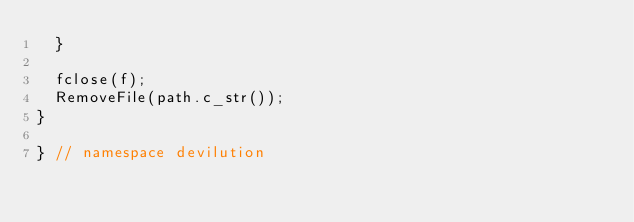Convert code to text. <code><loc_0><loc_0><loc_500><loc_500><_C++_>	}

	fclose(f);
	RemoveFile(path.c_str());
}

} // namespace devilution
</code> 